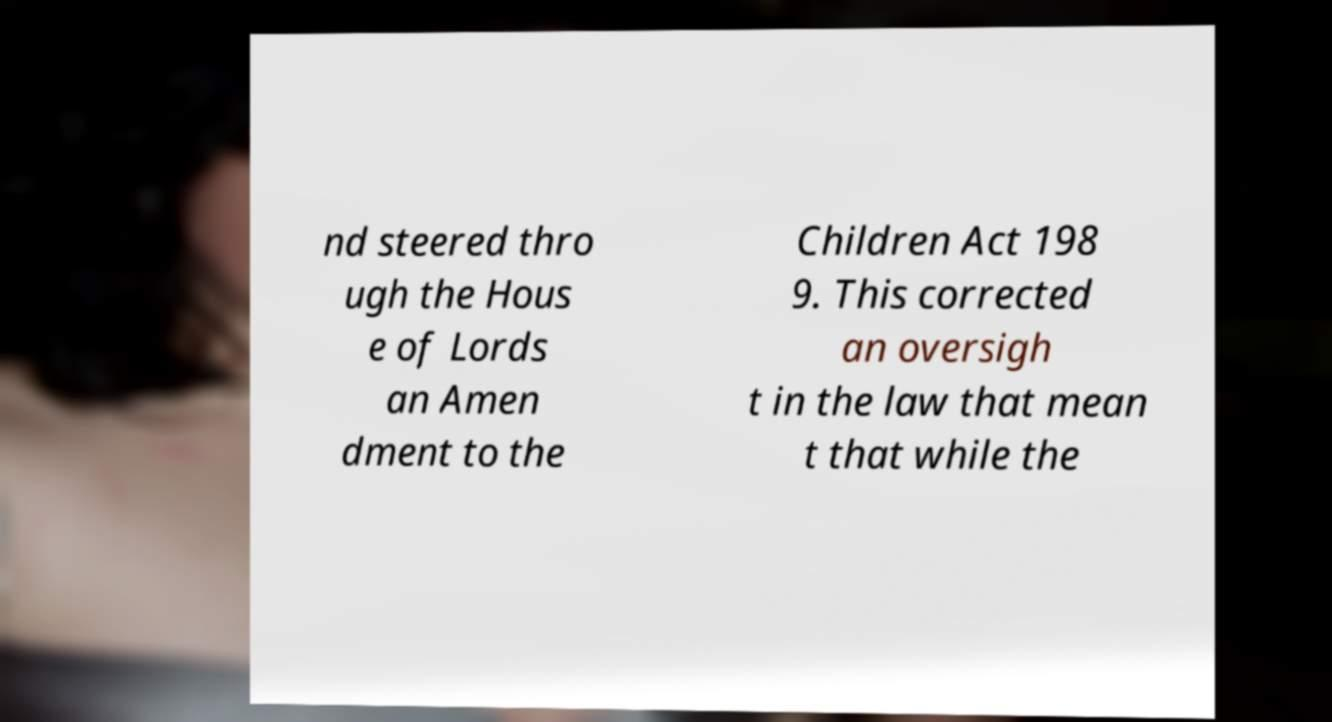Please read and relay the text visible in this image. What does it say? nd steered thro ugh the Hous e of Lords an Amen dment to the Children Act 198 9. This corrected an oversigh t in the law that mean t that while the 